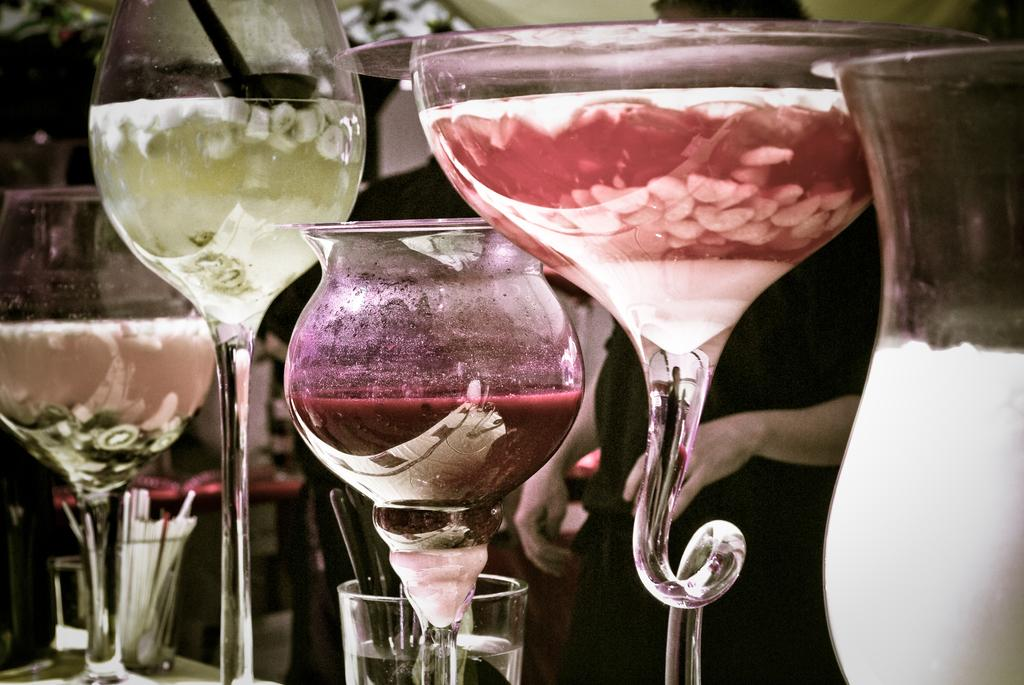What objects are in the middle of the picture? There are different types of glasses in the middle of the picture. What is inside the glasses? There are drinks in the glasses. Can you describe the background of the image? The background of the image is blurred. What type of key is used to unlock the drinks in the glasses? There is no key present in the image, and the drinks do not require unlocking. 